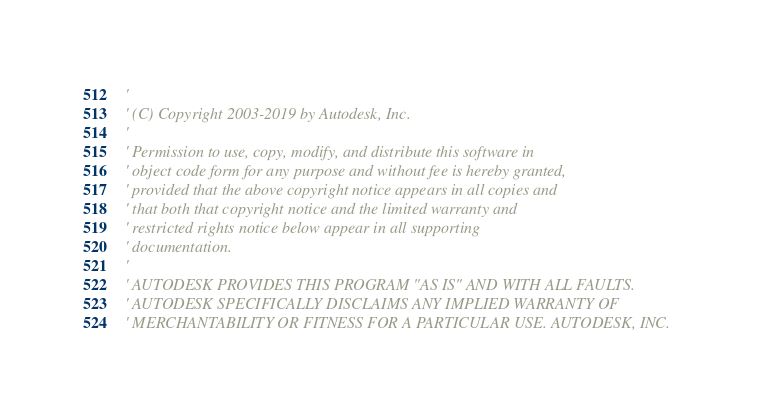Convert code to text. <code><loc_0><loc_0><loc_500><loc_500><_VisualBasic_>'
' (C) Copyright 2003-2019 by Autodesk, Inc.
'
' Permission to use, copy, modify, and distribute this software in
' object code form for any purpose and without fee is hereby granted,
' provided that the above copyright notice appears in all copies and
' that both that copyright notice and the limited warranty and
' restricted rights notice below appear in all supporting
' documentation.
'
' AUTODESK PROVIDES THIS PROGRAM "AS IS" AND WITH ALL FAULTS.
' AUTODESK SPECIFICALLY DISCLAIMS ANY IMPLIED WARRANTY OF
' MERCHANTABILITY OR FITNESS FOR A PARTICULAR USE. AUTODESK, INC.</code> 